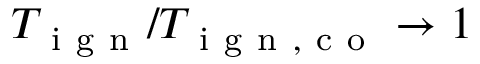Convert formula to latex. <formula><loc_0><loc_0><loc_500><loc_500>T _ { i g n } / T _ { i g n , c o } \rightarrow 1</formula> 